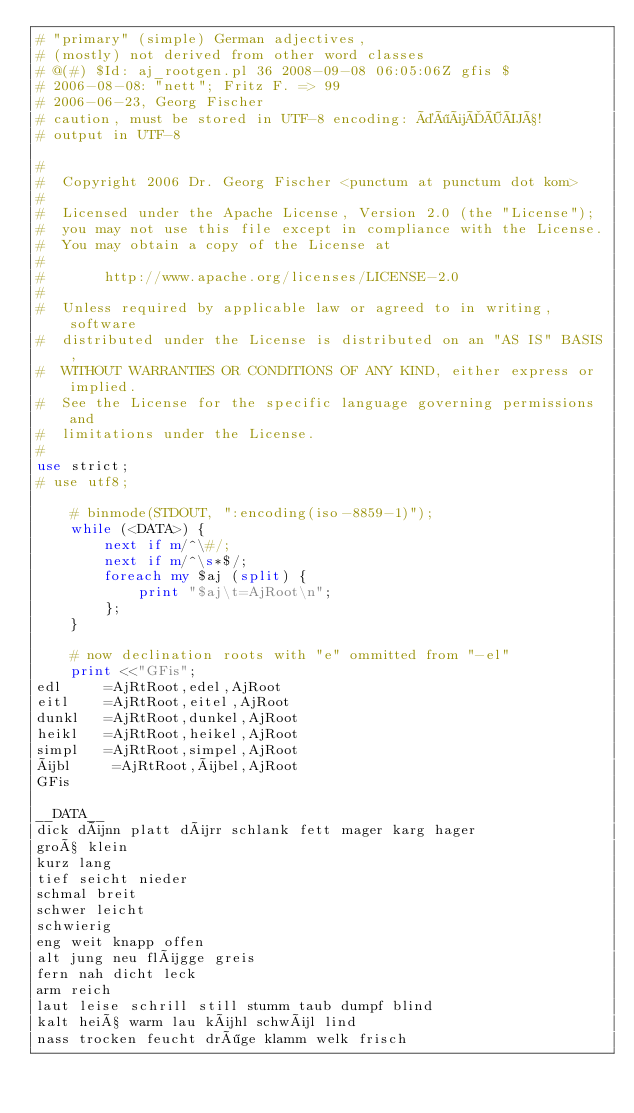Convert code to text. <code><loc_0><loc_0><loc_500><loc_500><_Perl_># "primary" (simple) German adjectives, 
# (mostly) not derived from other word classes
# @(#) $Id: aj_rootgen.pl 36 2008-09-08 06:05:06Z gfis $
# 2006-08-08: "nett"; Fritz F. => 99
# 2006-06-23, Georg Fischer
# caution, must be stored in UTF-8 encoding: äöüÄÖÜß!
# output in UTF-8

#
#  Copyright 2006 Dr. Georg Fischer <punctum at punctum dot kom>
# 
#  Licensed under the Apache License, Version 2.0 (the "License");
#  you may not use this file except in compliance with the License.
#  You may obtain a copy of the License at
# 
#       http://www.apache.org/licenses/LICENSE-2.0
# 
#  Unless required by applicable law or agreed to in writing, software
#  distributed under the License is distributed on an "AS IS" BASIS,
#  WITHOUT WARRANTIES OR CONDITIONS OF ANY KIND, either express or implied.
#  See the License for the specific language governing permissions and
#  limitations under the License.
#
use strict;
# use utf8;
    
    # binmode(STDOUT, ":encoding(iso-8859-1)");
    while (<DATA>) {
        next if m/^\#/;
        next if m/^\s*$/;
        foreach my $aj (split) {
            print "$aj\t=AjRoot\n";
        };
    }
    
    # now declination roots with "e" ommitted from "-el"
    print <<"GFis";
edl     =AjRtRoot,edel,AjRoot
eitl    =AjRtRoot,eitel,AjRoot
dunkl   =AjRtRoot,dunkel,AjRoot
heikl   =AjRtRoot,heikel,AjRoot
simpl   =AjRtRoot,simpel,AjRoot
übl     =AjRtRoot,übel,AjRoot
GFis

__DATA__
dick dünn platt dürr schlank fett mager karg hager 
groß klein
kurz lang
tief seicht nieder 
schmal breit
schwer leicht 
schwierig
eng weit knapp offen
alt jung neu flügge greis
fern nah dicht leck
arm reich
laut leise schrill still stumm taub dumpf blind
kalt heiß warm lau kühl schwül lind
nass trocken feucht dröge klamm welk frisch</code> 